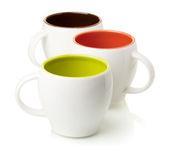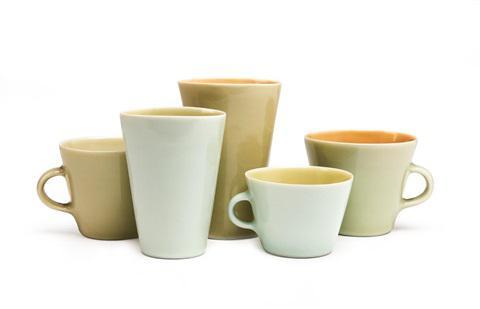The first image is the image on the left, the second image is the image on the right. Examine the images to the left and right. Is the description "An image shows exactly cups with white exteriors." accurate? Answer yes or no. Yes. The first image is the image on the left, the second image is the image on the right. Given the left and right images, does the statement "There are exactly three cups in each image in the pair." hold true? Answer yes or no. No. 